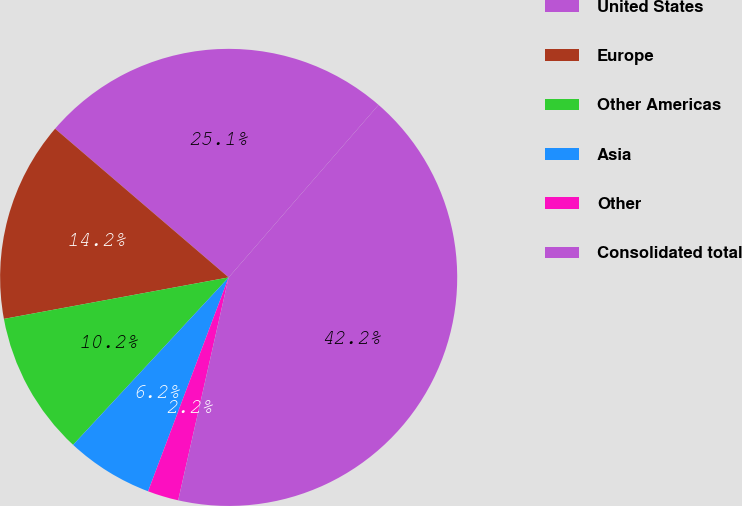Convert chart to OTSL. <chart><loc_0><loc_0><loc_500><loc_500><pie_chart><fcel>United States<fcel>Europe<fcel>Other Americas<fcel>Asia<fcel>Other<fcel>Consolidated total<nl><fcel>25.11%<fcel>14.18%<fcel>10.18%<fcel>6.18%<fcel>2.19%<fcel>42.16%<nl></chart> 